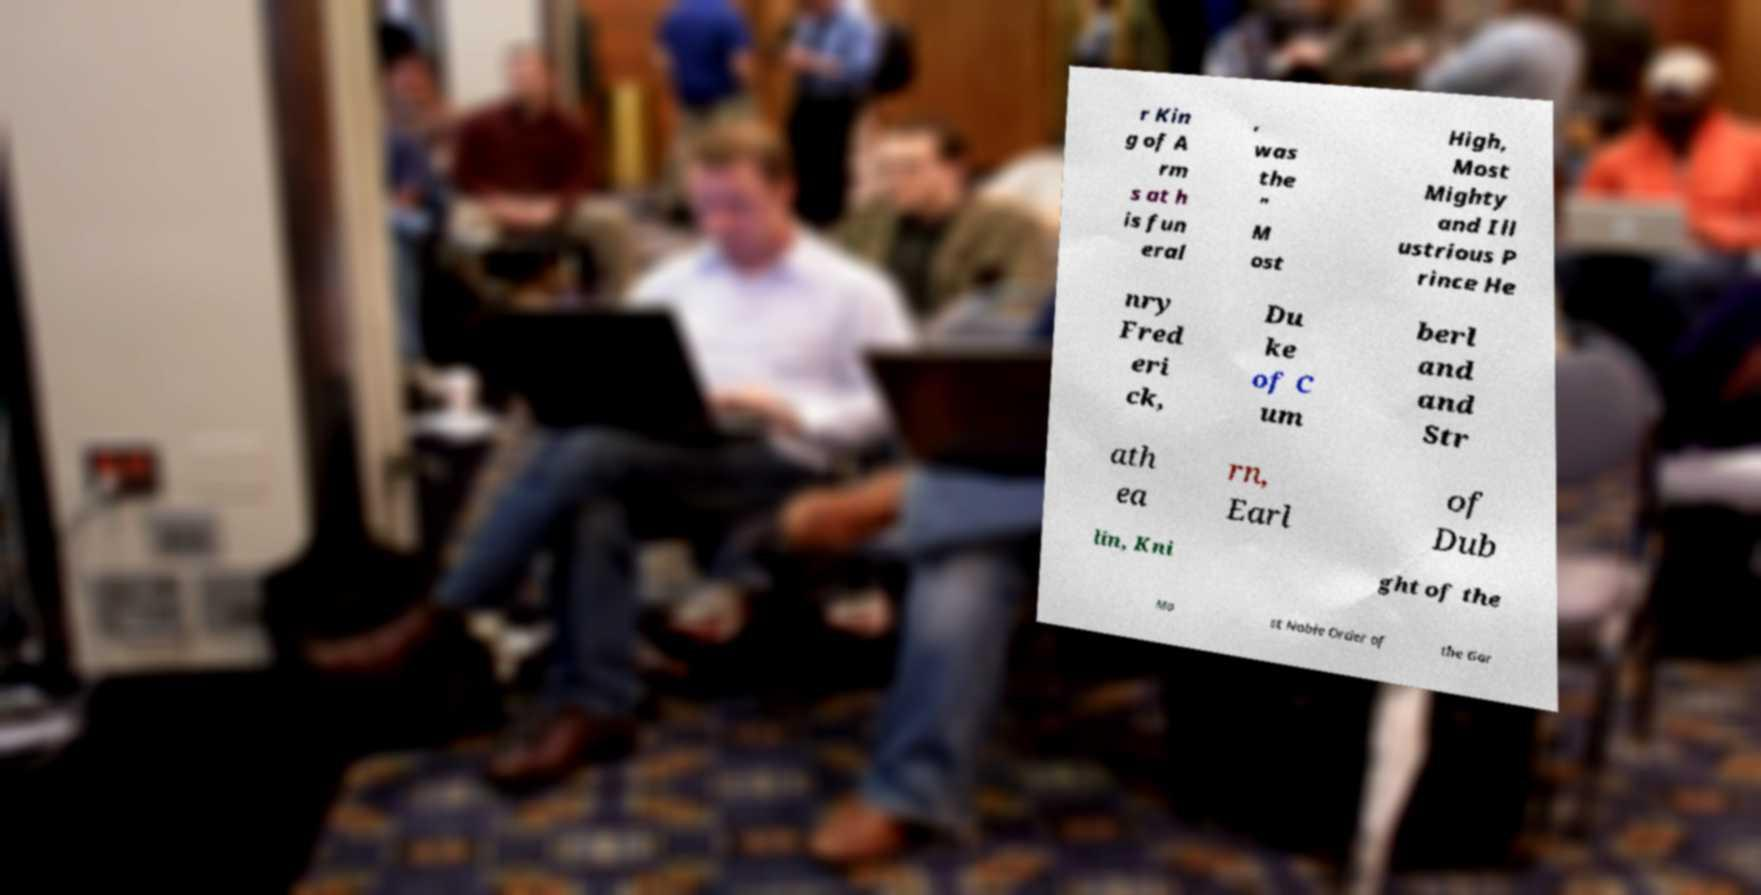Could you extract and type out the text from this image? r Kin g of A rm s at h is fun eral , was the " M ost High, Most Mighty and Ill ustrious P rince He nry Fred eri ck, Du ke of C um berl and and Str ath ea rn, Earl of Dub lin, Kni ght of the Mo st Noble Order of the Gar 